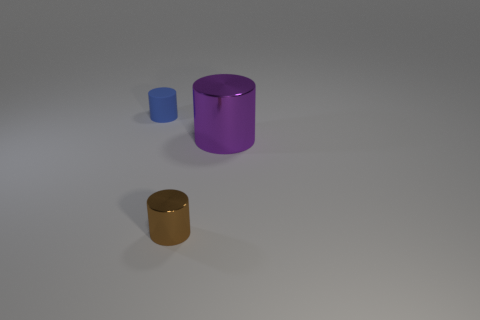Add 1 blue things. How many objects exist? 4 Subtract all green cylinders. Subtract all blue blocks. How many cylinders are left? 3 Subtract 0 red blocks. How many objects are left? 3 Subtract all tiny cylinders. Subtract all small blue matte objects. How many objects are left? 0 Add 1 small brown shiny cylinders. How many small brown shiny cylinders are left? 2 Add 1 large metal cylinders. How many large metal cylinders exist? 2 